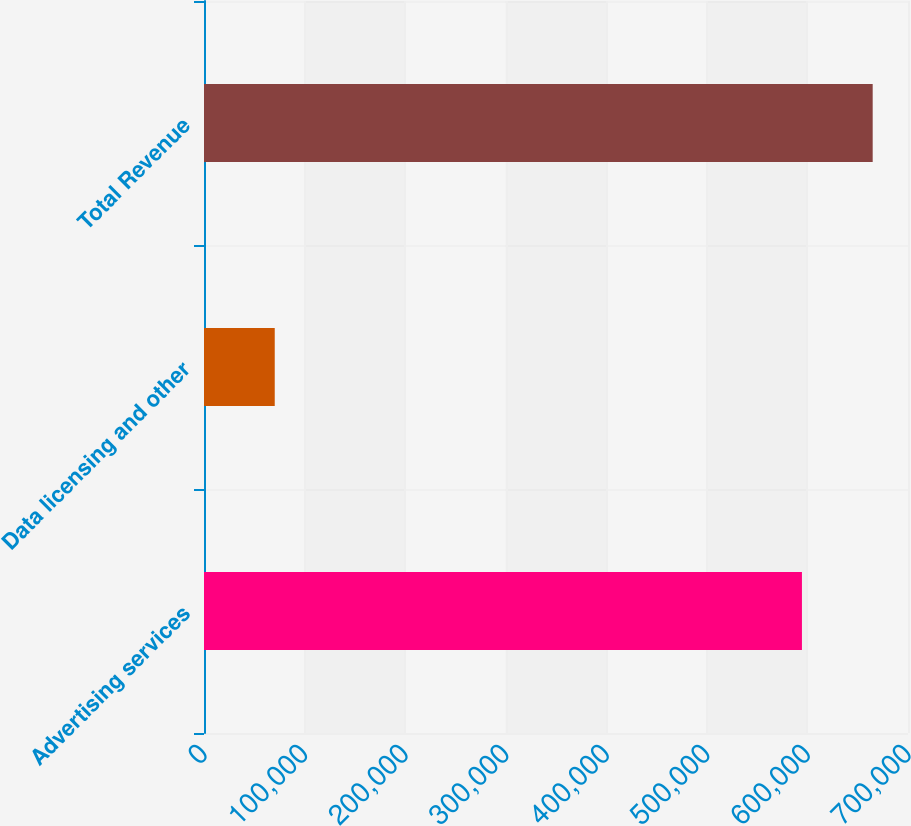Convert chart. <chart><loc_0><loc_0><loc_500><loc_500><bar_chart><fcel>Advertising services<fcel>Data licensing and other<fcel>Total Revenue<nl><fcel>594546<fcel>70344<fcel>664890<nl></chart> 